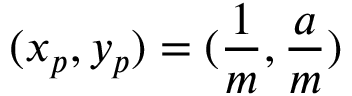Convert formula to latex. <formula><loc_0><loc_0><loc_500><loc_500>( x _ { p } , y _ { p } ) = ( \frac { 1 } { m } , \frac { a } { m } )</formula> 